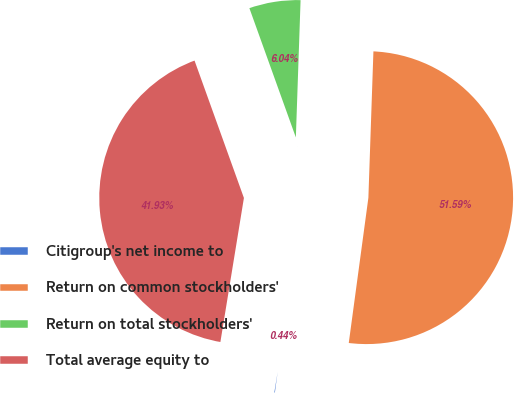Convert chart. <chart><loc_0><loc_0><loc_500><loc_500><pie_chart><fcel>Citigroup's net income to<fcel>Return on common stockholders'<fcel>Return on total stockholders'<fcel>Total average equity to<nl><fcel>0.44%<fcel>51.59%<fcel>6.04%<fcel>41.93%<nl></chart> 